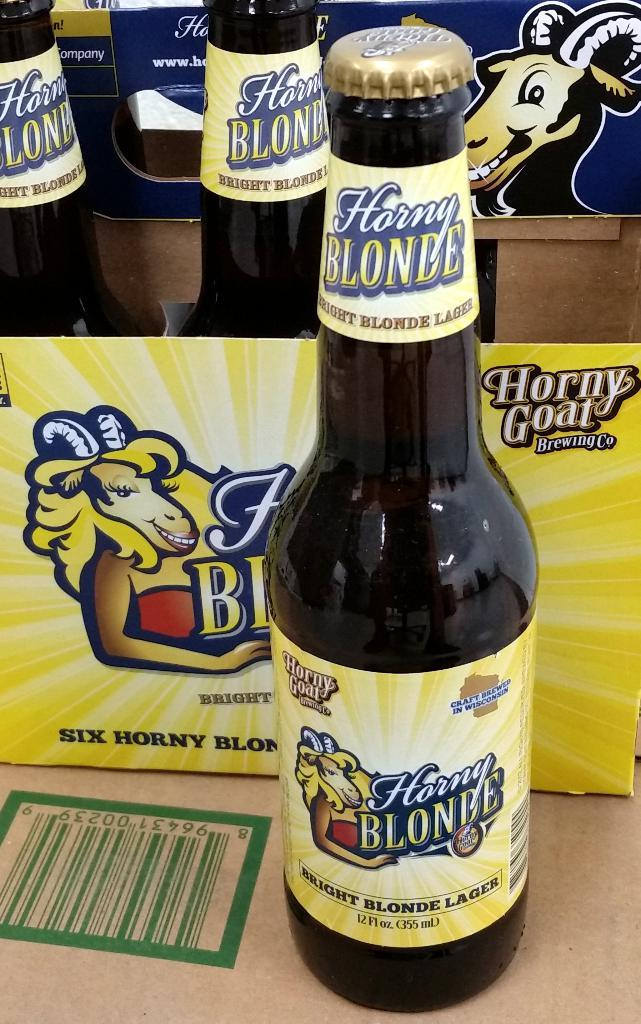<image>
Give a short and clear explanation of the subsequent image. A beer called Honey Blonde sits in front of the other bottles in the pack 